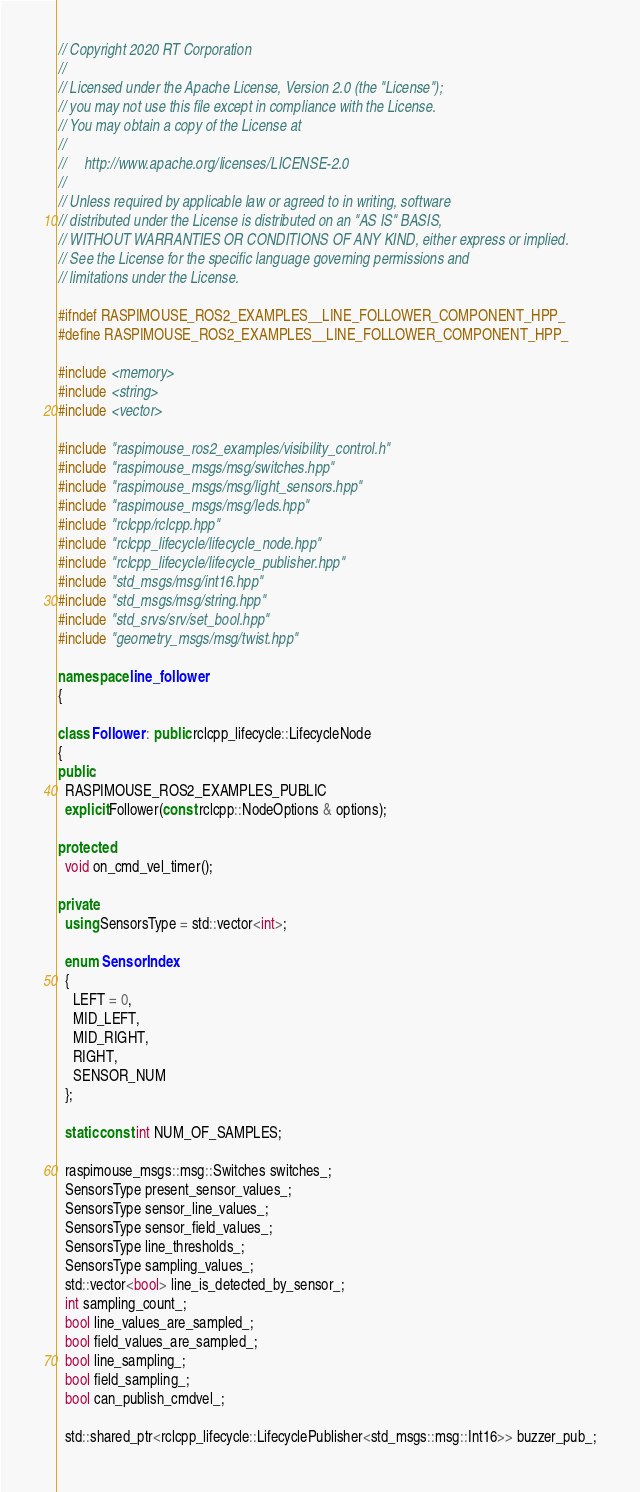Convert code to text. <code><loc_0><loc_0><loc_500><loc_500><_C++_>// Copyright 2020 RT Corporation
//
// Licensed under the Apache License, Version 2.0 (the "License");
// you may not use this file except in compliance with the License.
// You may obtain a copy of the License at
//
//     http://www.apache.org/licenses/LICENSE-2.0
//
// Unless required by applicable law or agreed to in writing, software
// distributed under the License is distributed on an "AS IS" BASIS,
// WITHOUT WARRANTIES OR CONDITIONS OF ANY KIND, either express or implied.
// See the License for the specific language governing permissions and
// limitations under the License.

#ifndef RASPIMOUSE_ROS2_EXAMPLES__LINE_FOLLOWER_COMPONENT_HPP_
#define RASPIMOUSE_ROS2_EXAMPLES__LINE_FOLLOWER_COMPONENT_HPP_

#include <memory>
#include <string>
#include <vector>

#include "raspimouse_ros2_examples/visibility_control.h"
#include "raspimouse_msgs/msg/switches.hpp"
#include "raspimouse_msgs/msg/light_sensors.hpp"
#include "raspimouse_msgs/msg/leds.hpp"
#include "rclcpp/rclcpp.hpp"
#include "rclcpp_lifecycle/lifecycle_node.hpp"
#include "rclcpp_lifecycle/lifecycle_publisher.hpp"
#include "std_msgs/msg/int16.hpp"
#include "std_msgs/msg/string.hpp"
#include "std_srvs/srv/set_bool.hpp"
#include "geometry_msgs/msg/twist.hpp"

namespace line_follower
{

class Follower : public rclcpp_lifecycle::LifecycleNode
{
public:
  RASPIMOUSE_ROS2_EXAMPLES_PUBLIC
  explicit Follower(const rclcpp::NodeOptions & options);

protected:
  void on_cmd_vel_timer();

private:
  using SensorsType = std::vector<int>;

  enum SensorIndex
  {
    LEFT = 0,
    MID_LEFT,
    MID_RIGHT,
    RIGHT,
    SENSOR_NUM
  };

  static const int NUM_OF_SAMPLES;

  raspimouse_msgs::msg::Switches switches_;
  SensorsType present_sensor_values_;
  SensorsType sensor_line_values_;
  SensorsType sensor_field_values_;
  SensorsType line_thresholds_;
  SensorsType sampling_values_;
  std::vector<bool> line_is_detected_by_sensor_;
  int sampling_count_;
  bool line_values_are_sampled_;
  bool field_values_are_sampled_;
  bool line_sampling_;
  bool field_sampling_;
  bool can_publish_cmdvel_;

  std::shared_ptr<rclcpp_lifecycle::LifecyclePublisher<std_msgs::msg::Int16>> buzzer_pub_;</code> 